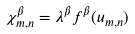Convert formula to latex. <formula><loc_0><loc_0><loc_500><loc_500>\chi ^ { \beta } _ { m , n } = \lambda ^ { \beta } f ^ { \beta } ( u _ { m , n } )</formula> 